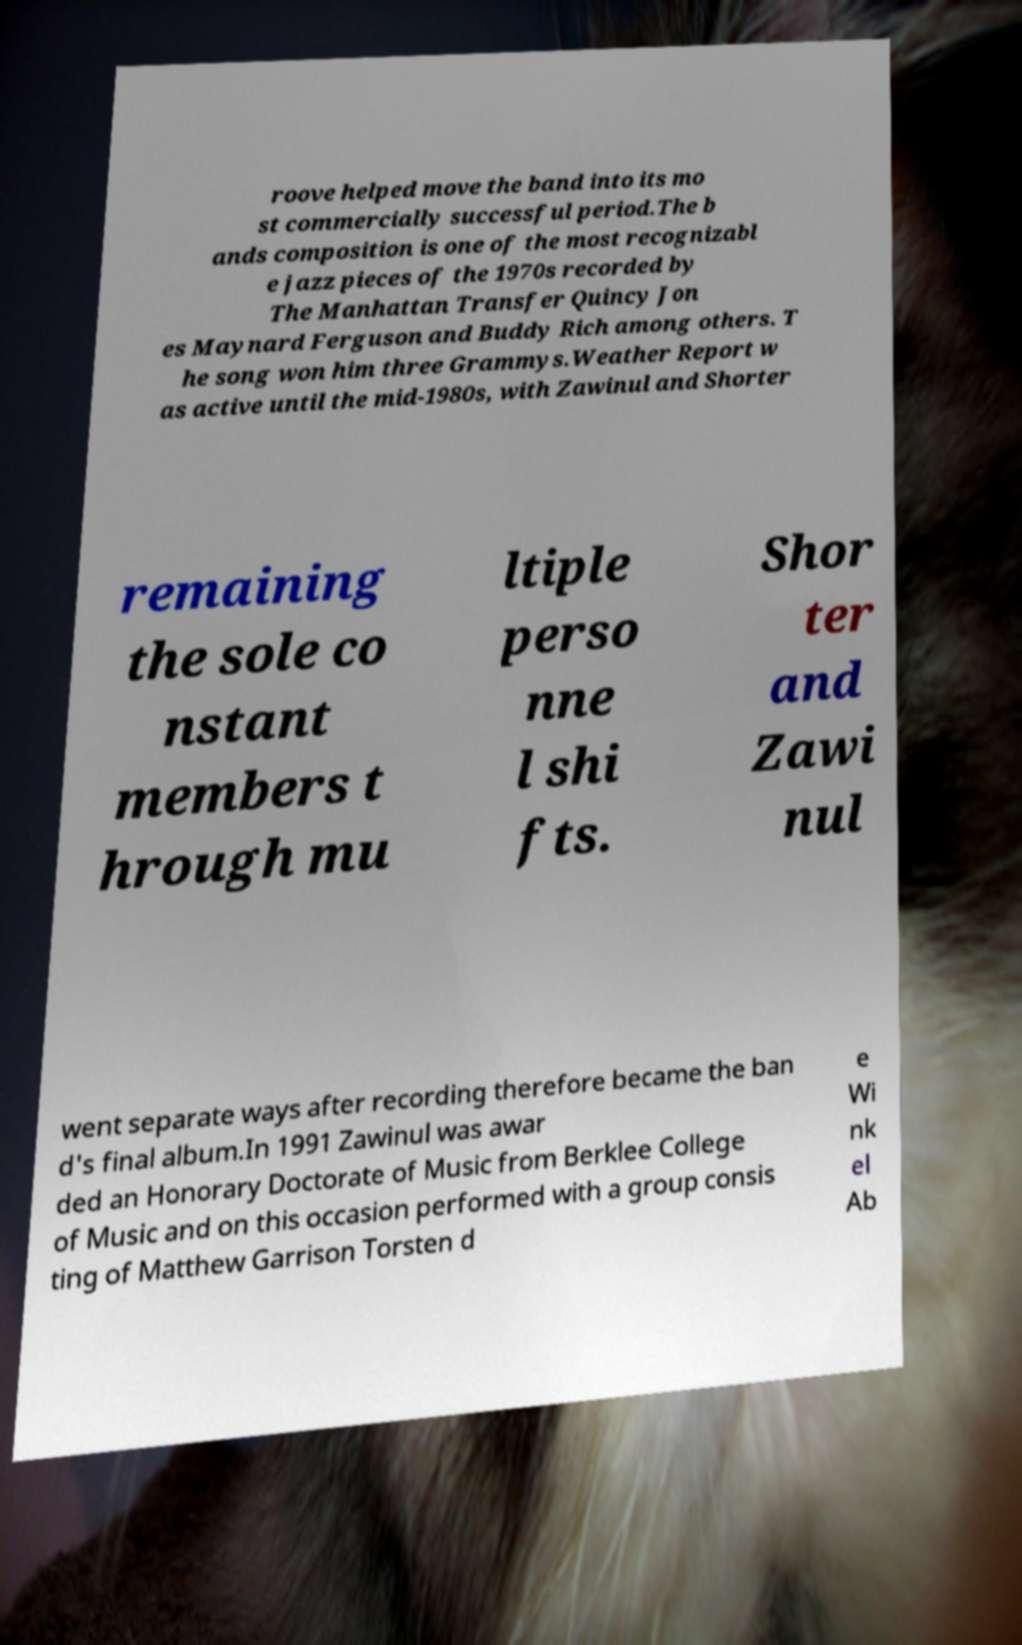There's text embedded in this image that I need extracted. Can you transcribe it verbatim? roove helped move the band into its mo st commercially successful period.The b ands composition is one of the most recognizabl e jazz pieces of the 1970s recorded by The Manhattan Transfer Quincy Jon es Maynard Ferguson and Buddy Rich among others. T he song won him three Grammys.Weather Report w as active until the mid-1980s, with Zawinul and Shorter remaining the sole co nstant members t hrough mu ltiple perso nne l shi fts. Shor ter and Zawi nul went separate ways after recording therefore became the ban d's final album.In 1991 Zawinul was awar ded an Honorary Doctorate of Music from Berklee College of Music and on this occasion performed with a group consis ting of Matthew Garrison Torsten d e Wi nk el Ab 